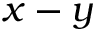Convert formula to latex. <formula><loc_0><loc_0><loc_500><loc_500>x - y</formula> 